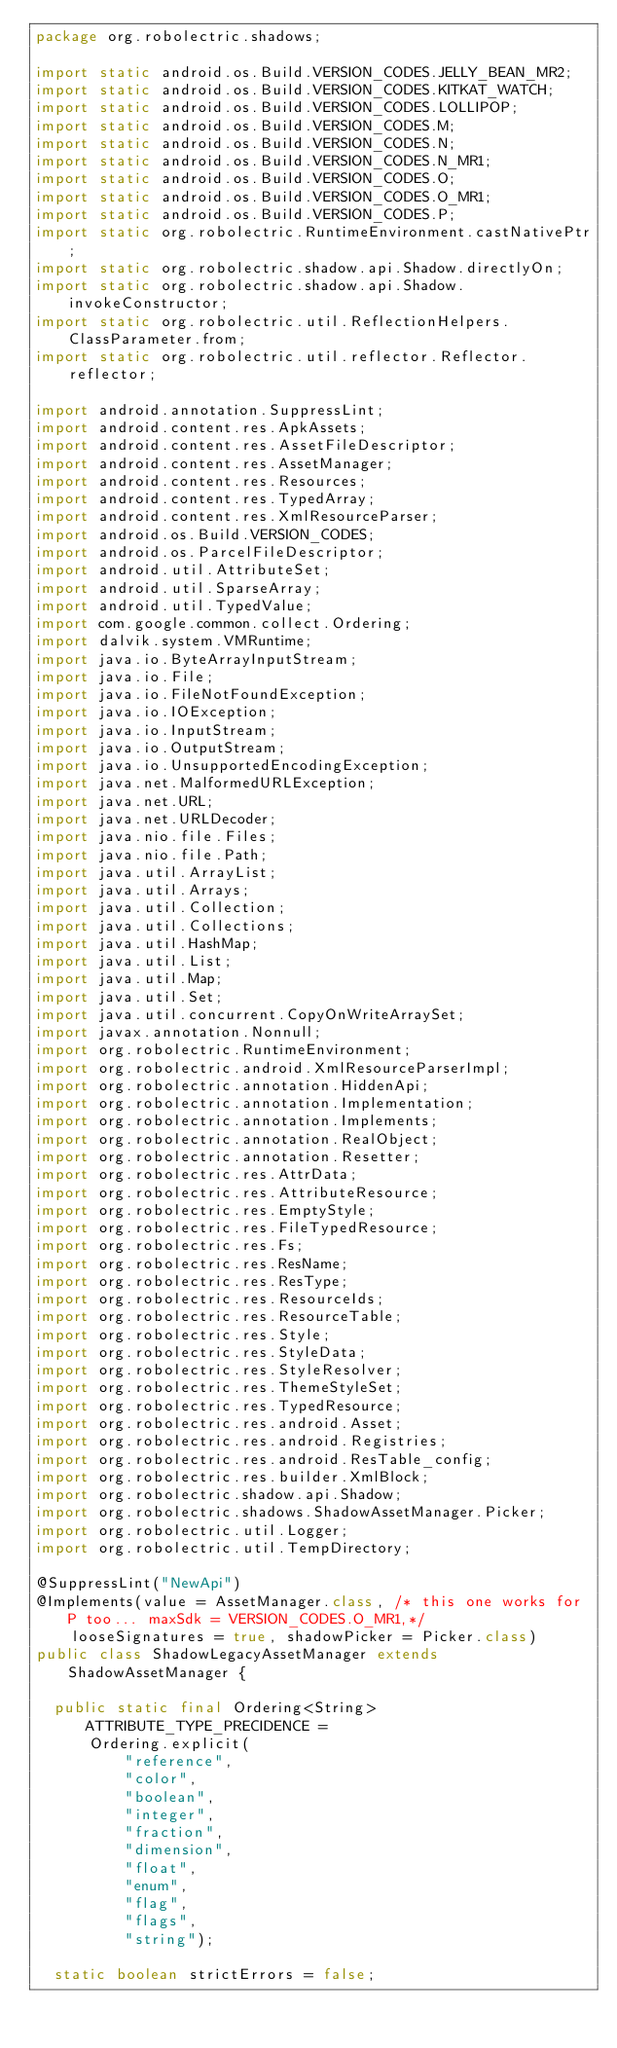Convert code to text. <code><loc_0><loc_0><loc_500><loc_500><_Java_>package org.robolectric.shadows;

import static android.os.Build.VERSION_CODES.JELLY_BEAN_MR2;
import static android.os.Build.VERSION_CODES.KITKAT_WATCH;
import static android.os.Build.VERSION_CODES.LOLLIPOP;
import static android.os.Build.VERSION_CODES.M;
import static android.os.Build.VERSION_CODES.N;
import static android.os.Build.VERSION_CODES.N_MR1;
import static android.os.Build.VERSION_CODES.O;
import static android.os.Build.VERSION_CODES.O_MR1;
import static android.os.Build.VERSION_CODES.P;
import static org.robolectric.RuntimeEnvironment.castNativePtr;
import static org.robolectric.shadow.api.Shadow.directlyOn;
import static org.robolectric.shadow.api.Shadow.invokeConstructor;
import static org.robolectric.util.ReflectionHelpers.ClassParameter.from;
import static org.robolectric.util.reflector.Reflector.reflector;

import android.annotation.SuppressLint;
import android.content.res.ApkAssets;
import android.content.res.AssetFileDescriptor;
import android.content.res.AssetManager;
import android.content.res.Resources;
import android.content.res.TypedArray;
import android.content.res.XmlResourceParser;
import android.os.Build.VERSION_CODES;
import android.os.ParcelFileDescriptor;
import android.util.AttributeSet;
import android.util.SparseArray;
import android.util.TypedValue;
import com.google.common.collect.Ordering;
import dalvik.system.VMRuntime;
import java.io.ByteArrayInputStream;
import java.io.File;
import java.io.FileNotFoundException;
import java.io.IOException;
import java.io.InputStream;
import java.io.OutputStream;
import java.io.UnsupportedEncodingException;
import java.net.MalformedURLException;
import java.net.URL;
import java.net.URLDecoder;
import java.nio.file.Files;
import java.nio.file.Path;
import java.util.ArrayList;
import java.util.Arrays;
import java.util.Collection;
import java.util.Collections;
import java.util.HashMap;
import java.util.List;
import java.util.Map;
import java.util.Set;
import java.util.concurrent.CopyOnWriteArraySet;
import javax.annotation.Nonnull;
import org.robolectric.RuntimeEnvironment;
import org.robolectric.android.XmlResourceParserImpl;
import org.robolectric.annotation.HiddenApi;
import org.robolectric.annotation.Implementation;
import org.robolectric.annotation.Implements;
import org.robolectric.annotation.RealObject;
import org.robolectric.annotation.Resetter;
import org.robolectric.res.AttrData;
import org.robolectric.res.AttributeResource;
import org.robolectric.res.EmptyStyle;
import org.robolectric.res.FileTypedResource;
import org.robolectric.res.Fs;
import org.robolectric.res.ResName;
import org.robolectric.res.ResType;
import org.robolectric.res.ResourceIds;
import org.robolectric.res.ResourceTable;
import org.robolectric.res.Style;
import org.robolectric.res.StyleData;
import org.robolectric.res.StyleResolver;
import org.robolectric.res.ThemeStyleSet;
import org.robolectric.res.TypedResource;
import org.robolectric.res.android.Asset;
import org.robolectric.res.android.Registries;
import org.robolectric.res.android.ResTable_config;
import org.robolectric.res.builder.XmlBlock;
import org.robolectric.shadow.api.Shadow;
import org.robolectric.shadows.ShadowAssetManager.Picker;
import org.robolectric.util.Logger;
import org.robolectric.util.TempDirectory;

@SuppressLint("NewApi")
@Implements(value = AssetManager.class, /* this one works for P too... maxSdk = VERSION_CODES.O_MR1,*/
    looseSignatures = true, shadowPicker = Picker.class)
public class ShadowLegacyAssetManager extends ShadowAssetManager {

  public static final Ordering<String> ATTRIBUTE_TYPE_PRECIDENCE =
      Ordering.explicit(
          "reference",
          "color",
          "boolean",
          "integer",
          "fraction",
          "dimension",
          "float",
          "enum",
          "flag",
          "flags",
          "string");

  static boolean strictErrors = false;
</code> 